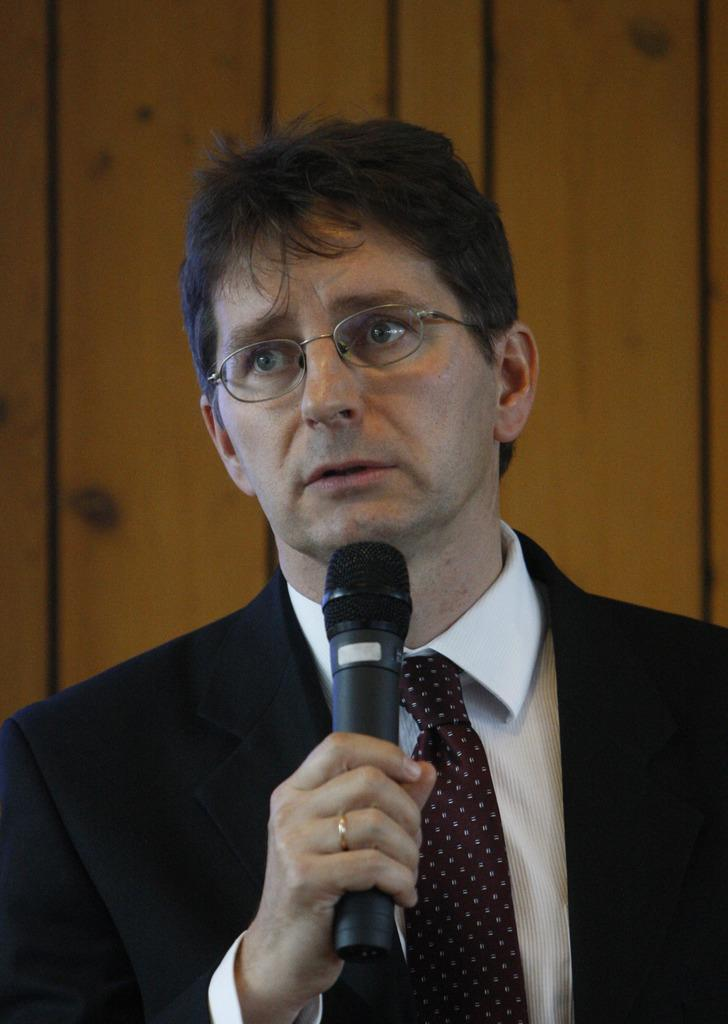What is the main subject of the image? There is a person in the image. What is the person doing in the image? The person is standing in the image. What object is the person holding in the image? The person is holding a microphone in the image. How many bikes can be seen in the image? There are no bikes present in the image. 